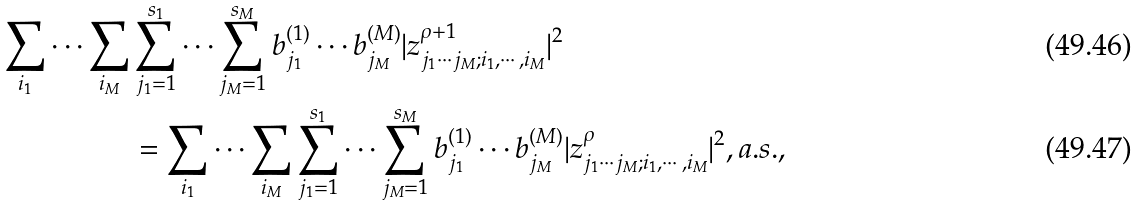Convert formula to latex. <formula><loc_0><loc_0><loc_500><loc_500>\sum _ { i _ { 1 } } \cdots \sum _ { i _ { M } } & \sum _ { j _ { 1 } = 1 } ^ { s _ { 1 } } \cdots \sum _ { j _ { M } = 1 } ^ { s _ { M } } b _ { j _ { 1 } } ^ { ( 1 ) } \cdots b _ { j _ { M } } ^ { ( M ) } | z _ { j _ { 1 } \cdots j _ { M } ; i _ { 1 } , \cdots , i _ { M } } ^ { \rho + 1 } | ^ { 2 } \\ & = \sum _ { i _ { 1 } } \cdots \sum _ { i _ { M } } \sum _ { j _ { 1 } = 1 } ^ { s _ { 1 } } \cdots \sum _ { j _ { M } = 1 } ^ { s _ { M } } b _ { j _ { 1 } } ^ { ( 1 ) } \cdots b _ { j _ { M } } ^ { ( M ) } | z _ { j _ { 1 } \cdots j _ { M } ; i _ { 1 } , \cdots , i _ { M } } ^ { \rho } | ^ { 2 } , a . s . ,</formula> 